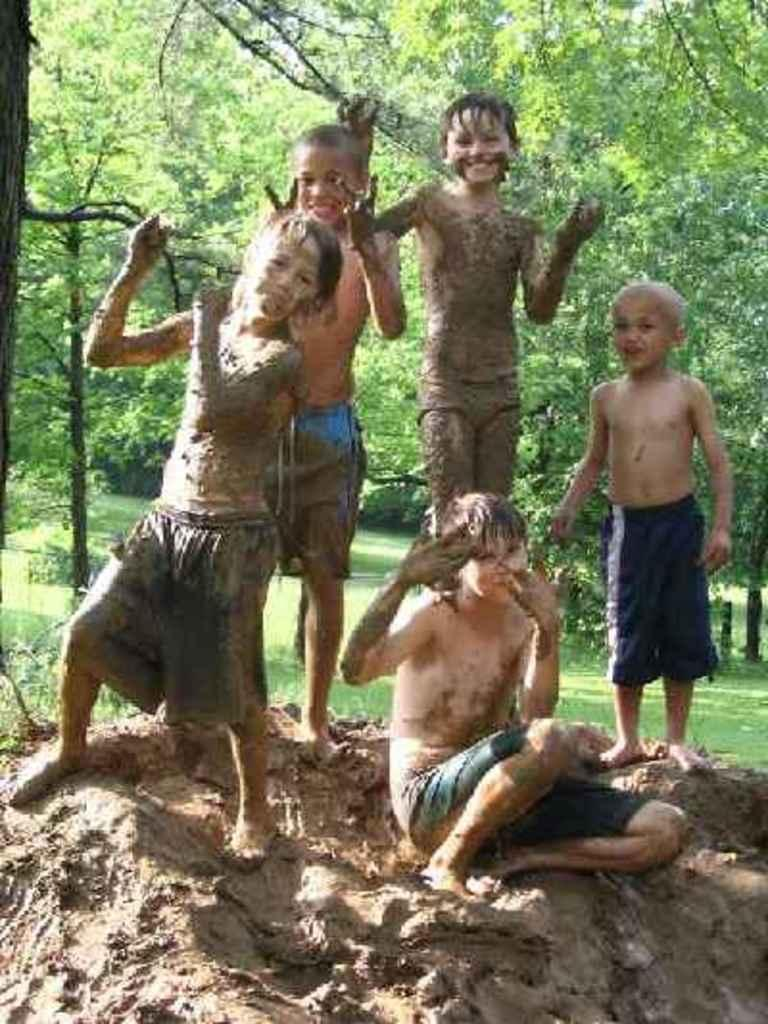How many people are covered in mud in the image? There are 5 people covered with mud in the image. What is the position of one of the people in the image? One person is sitting on the mud. How many people are standing in the image? Four people are standing in the image. What can be seen in the background of the image? There are trees visible in the background. What type of cloth is being used as a reward for the person sitting on the mud? There is no cloth or reward present in the image; it only shows people covered in mud. 